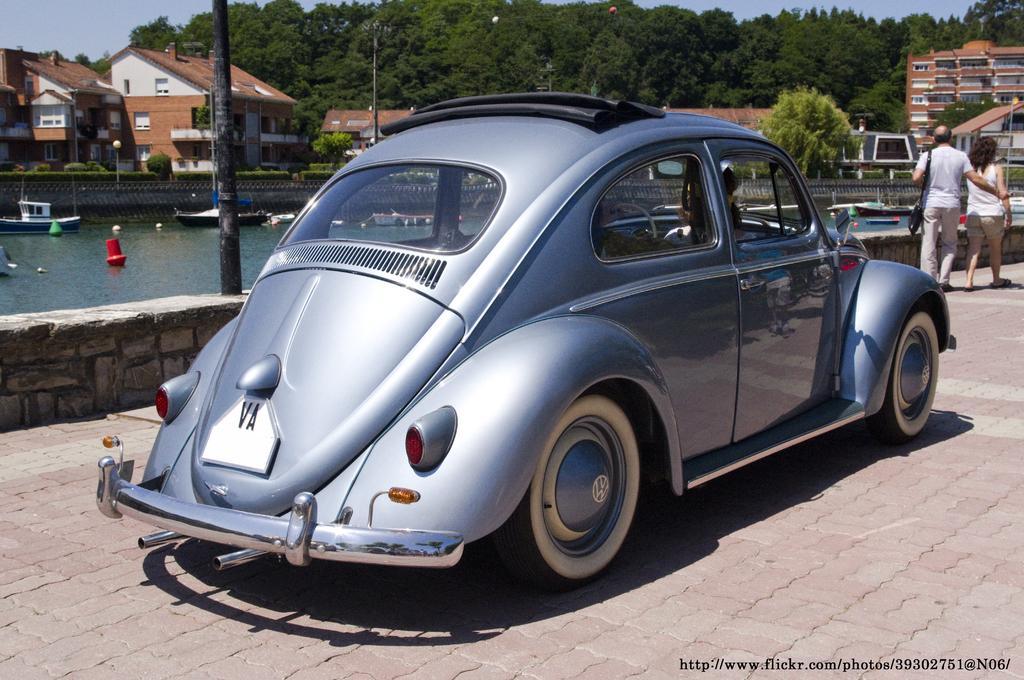Can you describe this image briefly? In this image, we can see few people are riding a car on the walkway. Background we can see water, boats, plants, houses, buildings, trees, poles and sky. Right side of the image, we can see two people are walking on the walkway. Right side bottom of the image, there is a watermark in the image. 